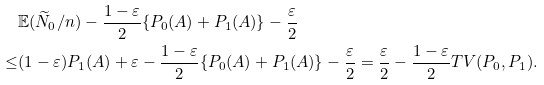<formula> <loc_0><loc_0><loc_500><loc_500>& \mathbb { E } ( \widetilde { N } _ { 0 } / n ) - \frac { 1 - \varepsilon } { 2 } \{ P _ { 0 } ( A ) + P _ { 1 } ( A ) \} - \frac { \varepsilon } { 2 } \\ \leq & ( 1 - \varepsilon ) P _ { 1 } ( A ) + \varepsilon - \frac { 1 - \varepsilon } { 2 } \{ P _ { 0 } ( A ) + P _ { 1 } ( A ) \} - \frac { \varepsilon } { 2 } = \frac { \varepsilon } { 2 } - \frac { 1 - \varepsilon } { 2 } T V ( P _ { 0 } , P _ { 1 } ) .</formula> 